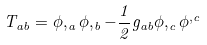Convert formula to latex. <formula><loc_0><loc_0><loc_500><loc_500>T _ { a b } = \phi , _ { a } \phi , _ { b } - \frac { 1 } { 2 } g _ { a b } \phi , _ { c } \phi ^ { , c }</formula> 